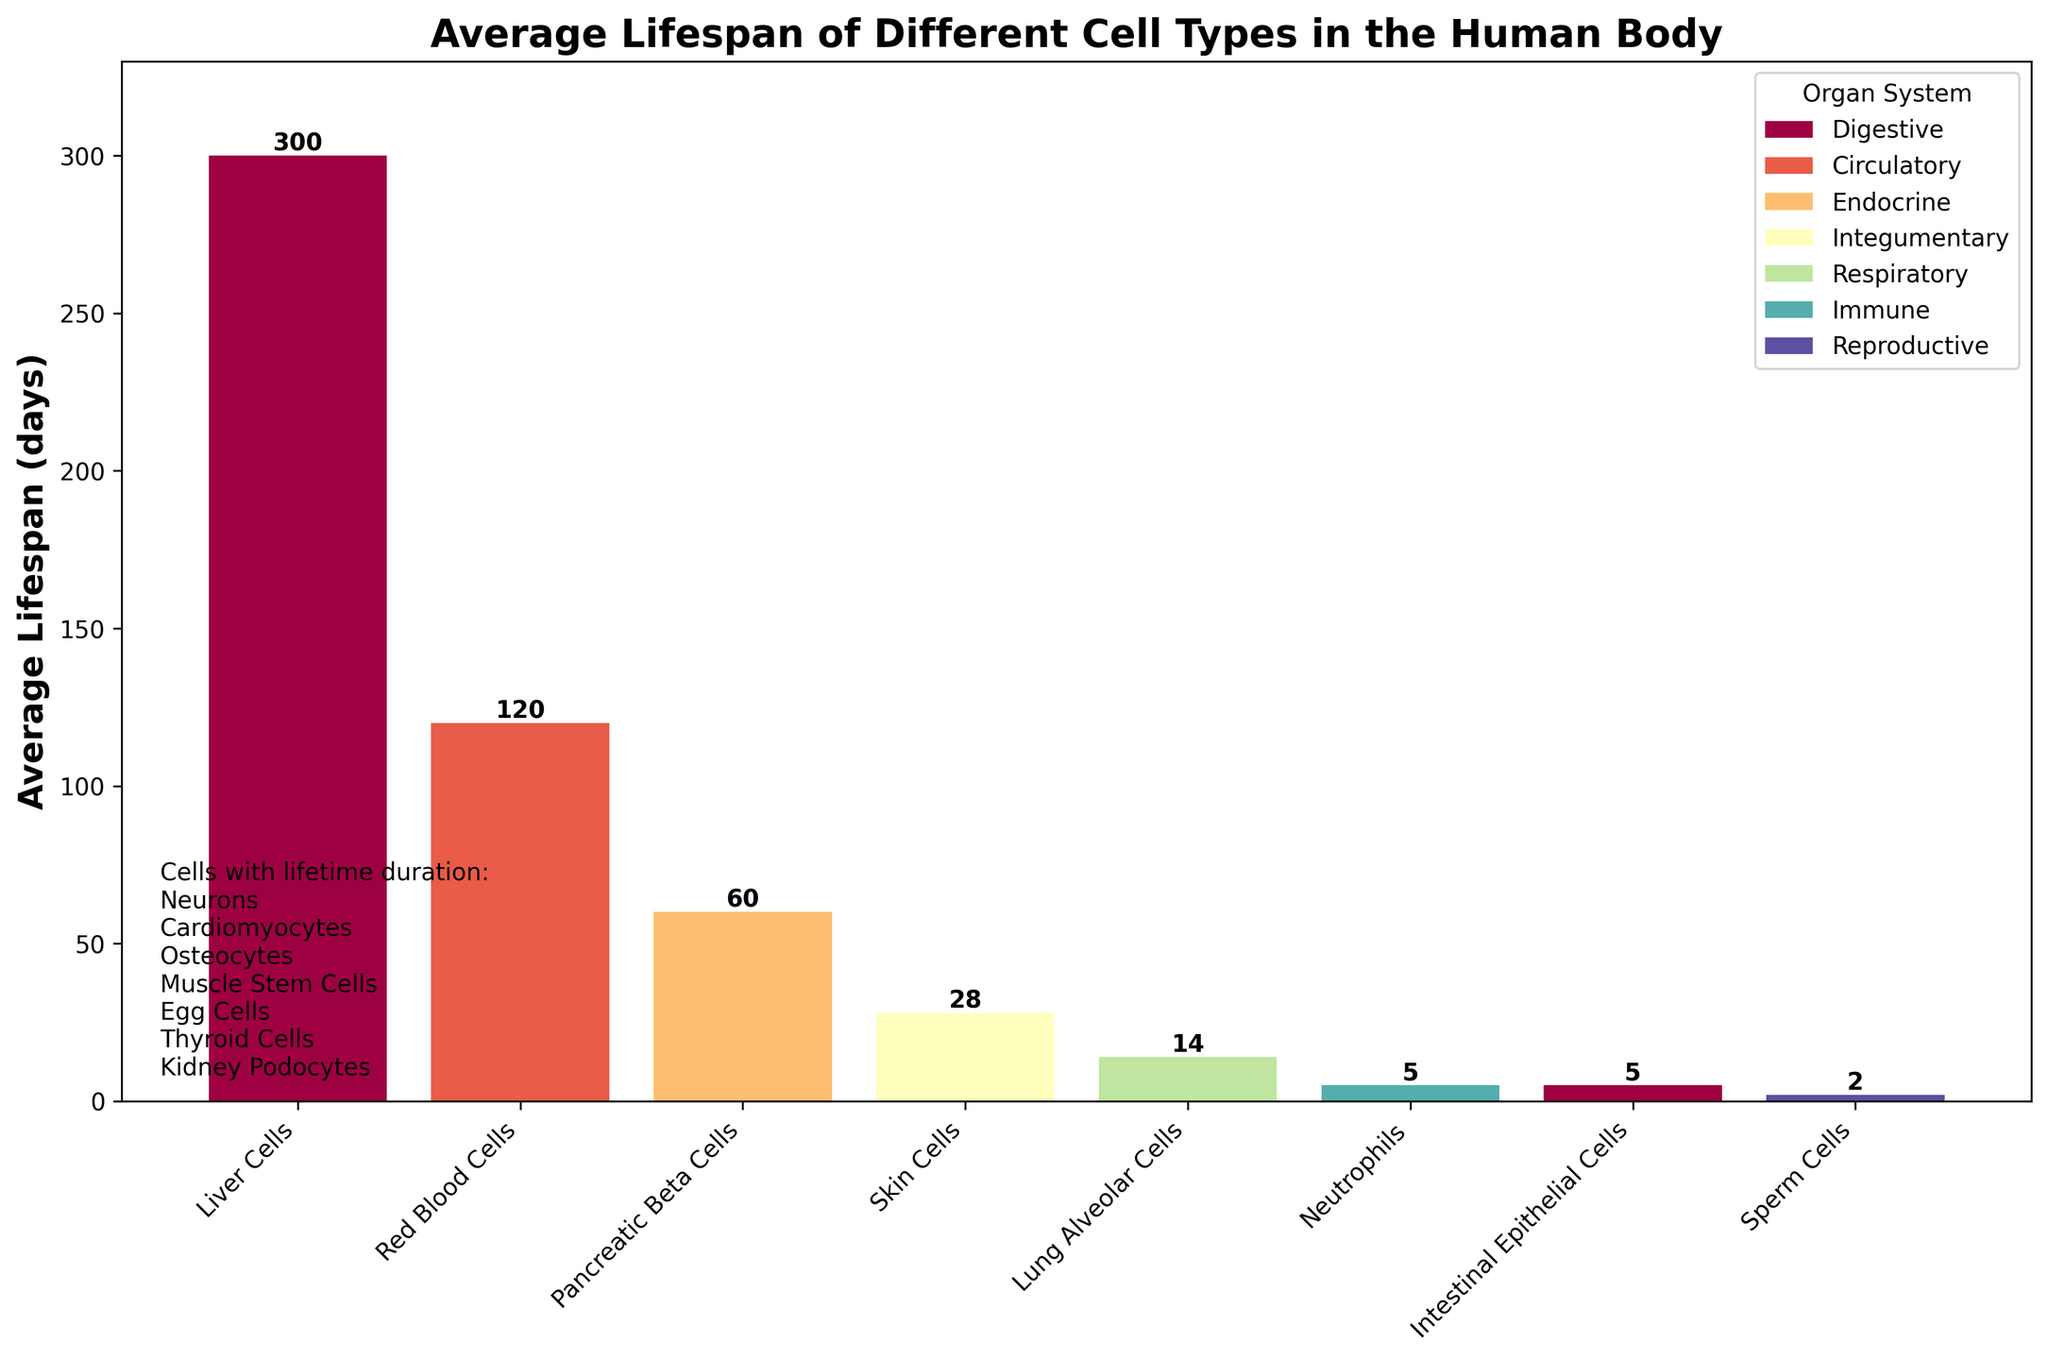Which cell type has the shortest average lifespan? To find the shortest lifespan, look for the bar with the smallest height in the bar chart. The shortest bar represents Sperm Cells with a lifespan of 2 days.
Answer: Sperm Cells Which organ system has the cell type with the longest finite lifespan? To determine this, look for the longest bar among the finite lifespan cell types. Liver Cells in the Digestive system have the longest finite lifespan of 300 days.
Answer: Digestive What is the total average lifespan of all cell types in the Immune and Integumentary systems? First, identify the cell types and their lifespans in these systems: Neutrophils (5 days) and Skin Cells (28 days). Sum the lifespans: 5 + 28 = 33 days.
Answer: 33 days How does the lifespan of Intestinal Epithelial Cells compare to Neutrophils? Compare the heights of the bars representing these cell types. Both bars have the same height, representing an equal lifespan of 5 days.
Answer: Equal Which cell type lives longer: Lung Alveolar Cells or Pancreatic Beta Cells? Compare the heights of the bars for Lung Alveolar Cells and Pancreatic Beta Cells. The Pancreatic Beta Cells bar is higher, indicating a longer lifespan of 60 days compared to 14 days for Lung Alveolar Cells.
Answer: Pancreatic Beta Cells What is the sum of average lifespans of Red Blood Cells, Skin Cells, and Lung Alveolar Cells? First, identify the lifespans: Red Blood Cells (120 days), Skin Cells (28 days), and Lung Alveolar Cells (14 days). Sum the lifespans: 120 + 28 + 14 = 162 days.
Answer: 162 days What is the median value of all the finite lifespans shown in the figure? List the lifespans in ascending order: 2, 5, 5, 14, 28, 60, 120, 300. The median is the average of the middle two values: (28 + 60) / 2 = 44 days.
Answer: 44 days What color represents the cells in the Circulatory system? Look at the legend in the figure. The color associated with the Circulatory system is shown next to its name in the legend.
Answer: (Color from the colormap representing the Circulatory system) Are there more cell types with 'finite' or 'lifetime' duration? Count the number of cell types in both categories: 8 finite lifespans and 7 lifetime categories. There are more finite lifespan cell types.
Answer: Finite 